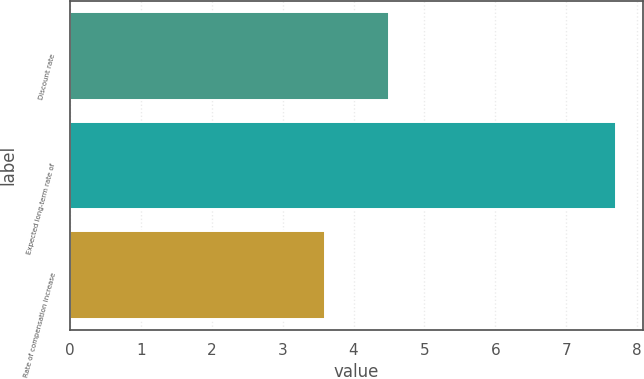Convert chart. <chart><loc_0><loc_0><loc_500><loc_500><bar_chart><fcel>Discount rate<fcel>Expected long-term rate of<fcel>Rate of compensation increase<nl><fcel>4.5<fcel>7.7<fcel>3.6<nl></chart> 